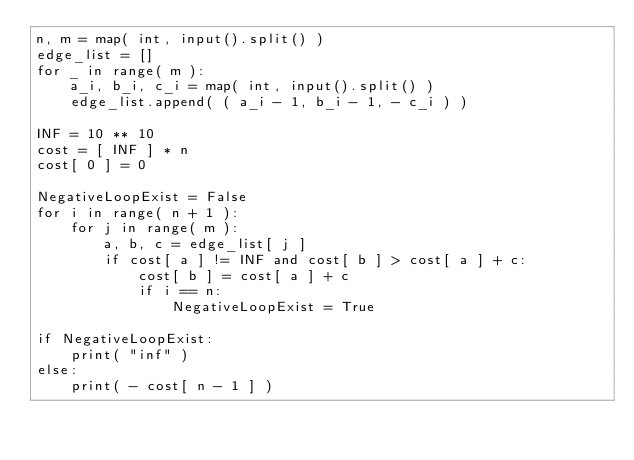Convert code to text. <code><loc_0><loc_0><loc_500><loc_500><_Python_>n, m = map( int, input().split() )
edge_list = []
for _ in range( m ):
    a_i, b_i, c_i = map( int, input().split() )
    edge_list.append( ( a_i - 1, b_i - 1, - c_i ) )

INF = 10 ** 10
cost = [ INF ] * n
cost[ 0 ] = 0

NegativeLoopExist = False
for i in range( n + 1 ):
    for j in range( m ):
        a, b, c = edge_list[ j ]
        if cost[ a ] != INF and cost[ b ] > cost[ a ] + c:
            cost[ b ] = cost[ a ] + c
            if i == n:
                NegativeLoopExist = True

if NegativeLoopExist:
    print( "inf" )
else:
    print( - cost[ n - 1 ] )</code> 